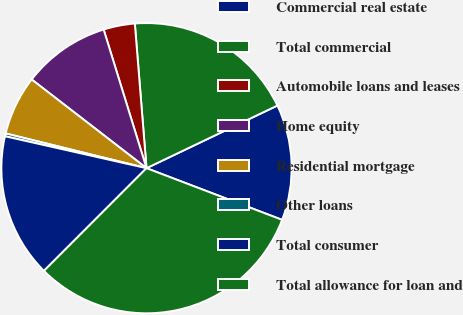<chart> <loc_0><loc_0><loc_500><loc_500><pie_chart><fcel>Commercial real estate<fcel>Total commercial<fcel>Automobile loans and leases<fcel>Home equity<fcel>Residential mortgage<fcel>Other loans<fcel>Total consumer<fcel>Total allowance for loan and<nl><fcel>12.9%<fcel>19.18%<fcel>3.49%<fcel>9.76%<fcel>6.62%<fcel>0.32%<fcel>16.04%<fcel>31.7%<nl></chart> 